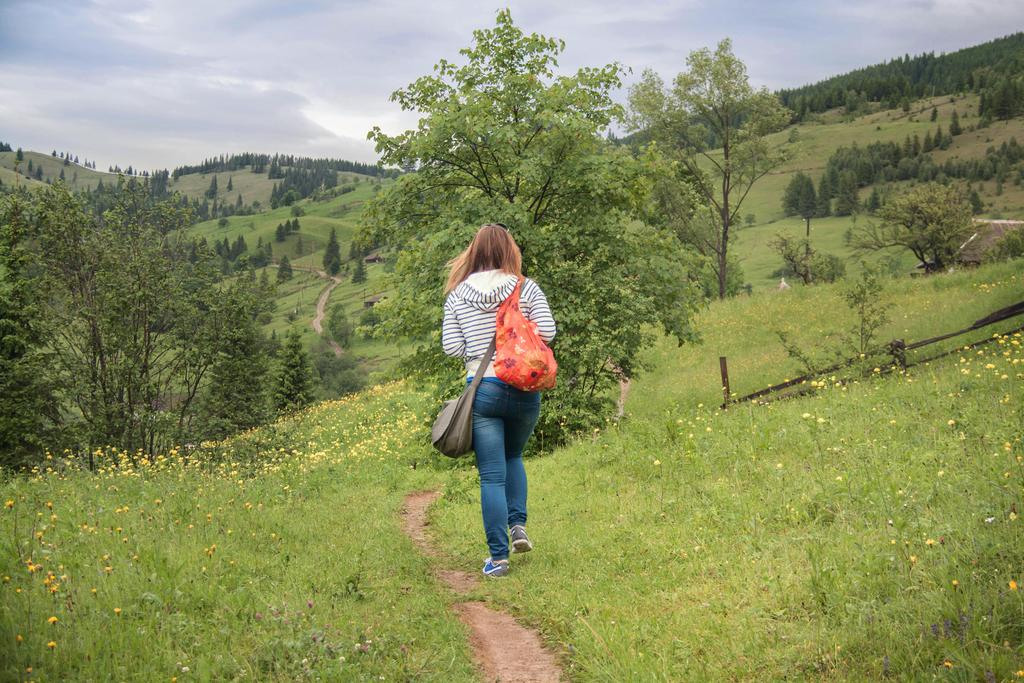Who is the main subject in the image? There is a woman in the image. What is the woman wearing? The woman is wearing bags. Where is the woman located in the image? The woman is walking on a grassland. What can be seen in the background of the image? There are trees, mountains, and the sky visible in the background of the image. What religious beliefs does the woman in the image follow? There is no information about the woman's religious beliefs in the image. What is the name of the governor in the image? There is no governor present in the image. 